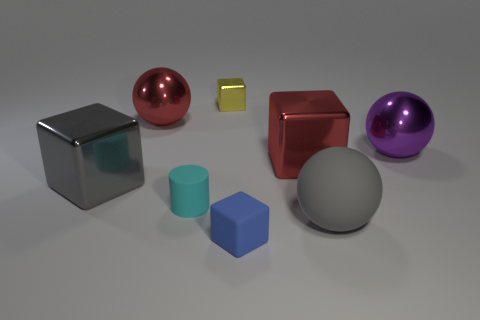Is there a big gray object on the right side of the big red object left of the tiny cyan rubber object?
Your response must be concise. Yes. How many cyan cylinders are behind the red metal block?
Your answer should be compact. 0. How many other things are the same color as the small metal block?
Offer a terse response. 0. Is the number of big gray rubber balls that are to the left of the small shiny object less than the number of spheres that are in front of the big purple object?
Offer a very short reply. Yes. What number of objects are matte things that are behind the small blue thing or small blue objects?
Ensure brevity in your answer.  3. Is the size of the purple metallic thing the same as the gray object right of the big gray metal thing?
Provide a short and direct response. Yes. There is a yellow object that is the same shape as the blue thing; what size is it?
Your answer should be very brief. Small. How many large cubes are behind the large metal block to the left of the red object right of the yellow cube?
Ensure brevity in your answer.  1. How many blocks are small green rubber things or large red objects?
Give a very brief answer. 1. There is a small thing that is behind the big thing that is behind the purple object in front of the yellow block; what color is it?
Make the answer very short. Yellow. 